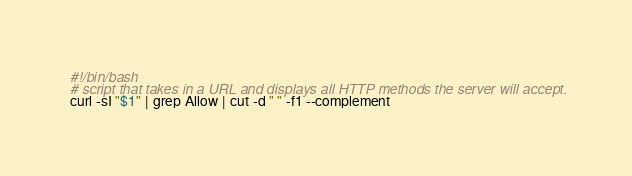<code> <loc_0><loc_0><loc_500><loc_500><_Bash_>#!/bin/bash
# script that takes in a URL and displays all HTTP methods the server will accept.
curl -sI "$1" | grep Allow | cut -d " " -f1 --complement
</code> 